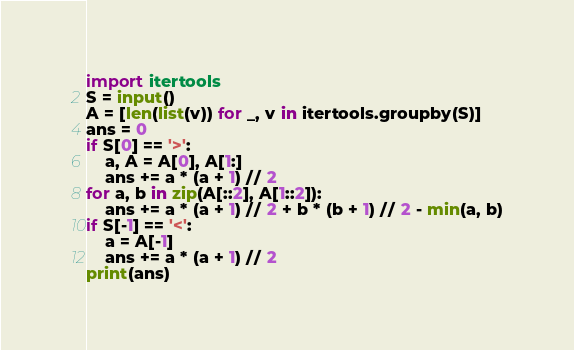Convert code to text. <code><loc_0><loc_0><loc_500><loc_500><_Python_>import itertools
S = input()
A = [len(list(v)) for _, v in itertools.groupby(S)]
ans = 0
if S[0] == '>':
    a, A = A[0], A[1:]
    ans += a * (a + 1) // 2
for a, b in zip(A[::2], A[1::2]):
    ans += a * (a + 1) // 2 + b * (b + 1) // 2 - min(a, b)
if S[-1] == '<':
    a = A[-1]
    ans += a * (a + 1) // 2
print(ans)
</code> 